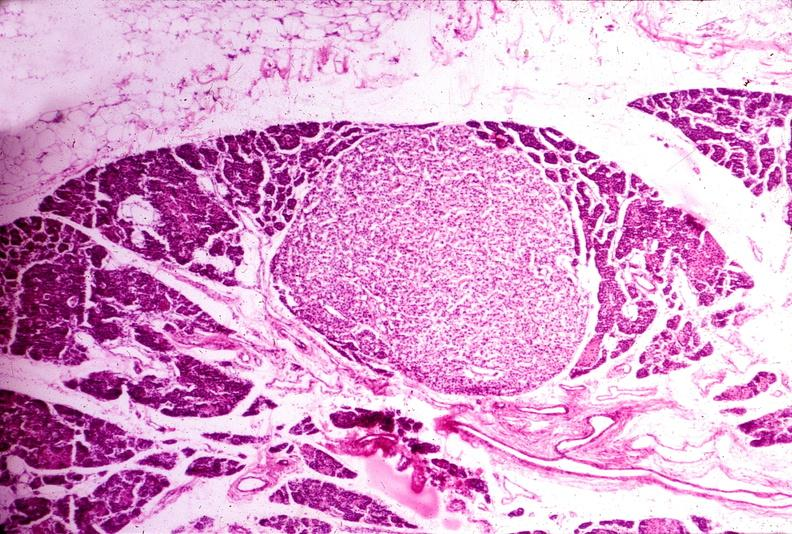where is this part in the figure?
Answer the question using a single word or phrase. Endocrine system 